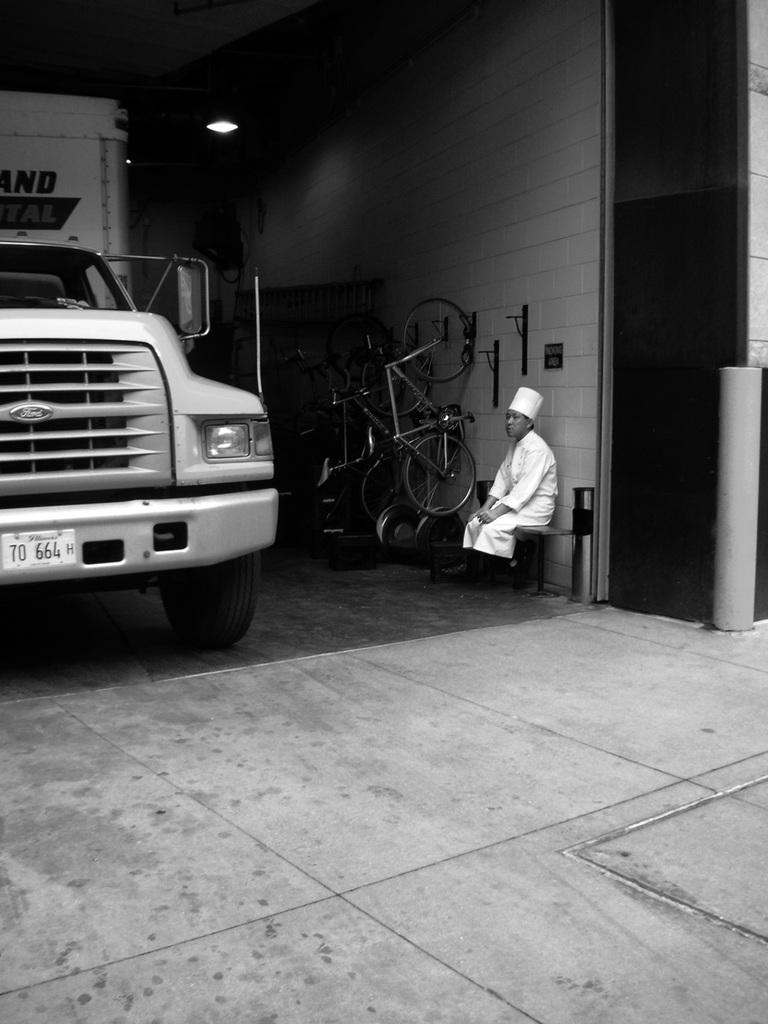Who is present in the image? There is a person in the image. What is the person wearing? The person is wearing a white dress. What is the person doing in the image? The person is sitting. What can be seen beside the person? There are bicycles beside the person. What is in front of the person? There is a vehicle in front of the person. What type of agreement is being discussed between the person and the bicycles in the image? There is no indication of any agreement being discussed in the image; it simply shows a person sitting with bicycles beside them. 